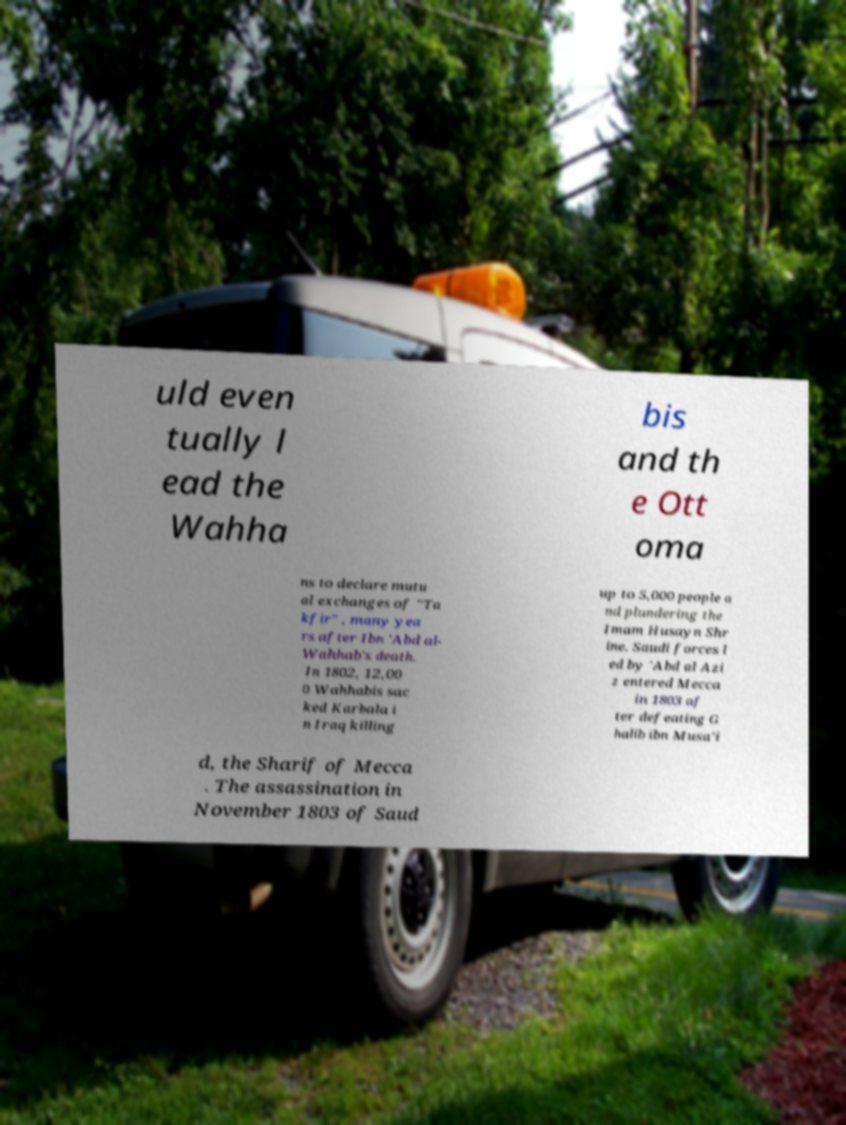Can you read and provide the text displayed in the image?This photo seems to have some interesting text. Can you extract and type it out for me? uld even tually l ead the Wahha bis and th e Ott oma ns to declare mutu al exchanges of "Ta kfir" , many yea rs after Ibn 'Abd al- Wahhab's death. In 1802, 12,00 0 Wahhabis sac ked Karbala i n Iraq killing up to 5,000 people a nd plundering the Imam Husayn Shr ine. Saudi forces l ed by 'Abd al Azi z entered Mecca in 1803 af ter defeating G halib ibn Musa'i d, the Sharif of Mecca . The assassination in November 1803 of Saud 